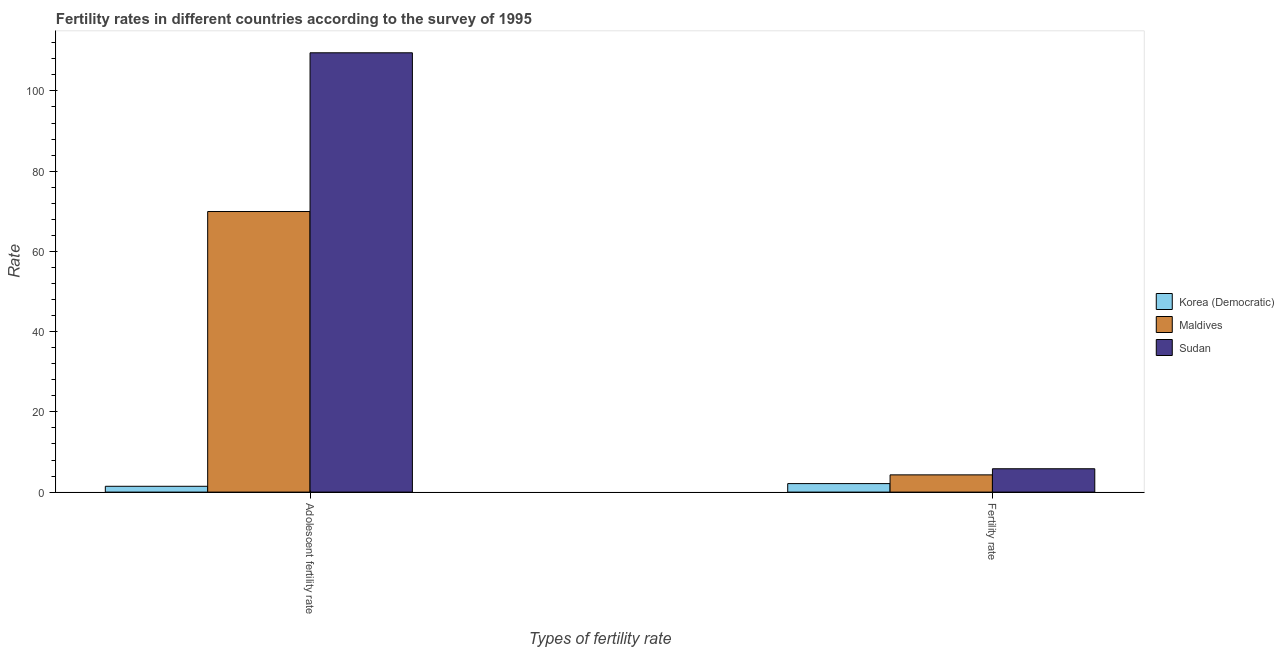Are the number of bars per tick equal to the number of legend labels?
Keep it short and to the point. Yes. Are the number of bars on each tick of the X-axis equal?
Your answer should be compact. Yes. How many bars are there on the 1st tick from the right?
Your response must be concise. 3. What is the label of the 1st group of bars from the left?
Keep it short and to the point. Adolescent fertility rate. What is the fertility rate in Korea (Democratic)?
Provide a short and direct response. 2.12. Across all countries, what is the maximum adolescent fertility rate?
Give a very brief answer. 109.5. Across all countries, what is the minimum fertility rate?
Your answer should be compact. 2.12. In which country was the adolescent fertility rate maximum?
Give a very brief answer. Sudan. In which country was the fertility rate minimum?
Your response must be concise. Korea (Democratic). What is the total adolescent fertility rate in the graph?
Provide a short and direct response. 180.89. What is the difference between the adolescent fertility rate in Sudan and that in Maldives?
Give a very brief answer. 39.56. What is the difference between the adolescent fertility rate in Maldives and the fertility rate in Korea (Democratic)?
Your answer should be compact. 67.82. What is the average adolescent fertility rate per country?
Make the answer very short. 60.3. What is the difference between the adolescent fertility rate and fertility rate in Maldives?
Provide a short and direct response. 65.64. In how many countries, is the fertility rate greater than 96 ?
Offer a terse response. 0. What is the ratio of the adolescent fertility rate in Sudan to that in Maldives?
Ensure brevity in your answer.  1.57. Is the adolescent fertility rate in Maldives less than that in Korea (Democratic)?
Provide a short and direct response. No. In how many countries, is the adolescent fertility rate greater than the average adolescent fertility rate taken over all countries?
Keep it short and to the point. 2. What does the 2nd bar from the left in Adolescent fertility rate represents?
Keep it short and to the point. Maldives. What does the 1st bar from the right in Adolescent fertility rate represents?
Offer a very short reply. Sudan. How many countries are there in the graph?
Your answer should be very brief. 3. Does the graph contain any zero values?
Provide a succinct answer. No. Where does the legend appear in the graph?
Your response must be concise. Center right. How many legend labels are there?
Offer a terse response. 3. What is the title of the graph?
Your answer should be compact. Fertility rates in different countries according to the survey of 1995. What is the label or title of the X-axis?
Your response must be concise. Types of fertility rate. What is the label or title of the Y-axis?
Your response must be concise. Rate. What is the Rate in Korea (Democratic) in Adolescent fertility rate?
Provide a succinct answer. 1.45. What is the Rate of Maldives in Adolescent fertility rate?
Your answer should be compact. 69.94. What is the Rate of Sudan in Adolescent fertility rate?
Make the answer very short. 109.5. What is the Rate in Korea (Democratic) in Fertility rate?
Provide a succinct answer. 2.12. What is the Rate of Maldives in Fertility rate?
Keep it short and to the point. 4.3. What is the Rate of Sudan in Fertility rate?
Keep it short and to the point. 5.82. Across all Types of fertility rate, what is the maximum Rate of Korea (Democratic)?
Your response must be concise. 2.12. Across all Types of fertility rate, what is the maximum Rate of Maldives?
Ensure brevity in your answer.  69.94. Across all Types of fertility rate, what is the maximum Rate in Sudan?
Your answer should be very brief. 109.5. Across all Types of fertility rate, what is the minimum Rate of Korea (Democratic)?
Offer a terse response. 1.45. Across all Types of fertility rate, what is the minimum Rate in Maldives?
Provide a succinct answer. 4.3. Across all Types of fertility rate, what is the minimum Rate of Sudan?
Your answer should be very brief. 5.82. What is the total Rate of Korea (Democratic) in the graph?
Your response must be concise. 3.57. What is the total Rate in Maldives in the graph?
Your answer should be very brief. 74.24. What is the total Rate in Sudan in the graph?
Your response must be concise. 115.32. What is the difference between the Rate in Korea (Democratic) in Adolescent fertility rate and that in Fertility rate?
Provide a succinct answer. -0.67. What is the difference between the Rate in Maldives in Adolescent fertility rate and that in Fertility rate?
Give a very brief answer. 65.64. What is the difference between the Rate of Sudan in Adolescent fertility rate and that in Fertility rate?
Your answer should be compact. 103.68. What is the difference between the Rate in Korea (Democratic) in Adolescent fertility rate and the Rate in Maldives in Fertility rate?
Give a very brief answer. -2.85. What is the difference between the Rate of Korea (Democratic) in Adolescent fertility rate and the Rate of Sudan in Fertility rate?
Make the answer very short. -4.37. What is the difference between the Rate in Maldives in Adolescent fertility rate and the Rate in Sudan in Fertility rate?
Ensure brevity in your answer.  64.12. What is the average Rate of Korea (Democratic) per Types of fertility rate?
Give a very brief answer. 1.79. What is the average Rate of Maldives per Types of fertility rate?
Give a very brief answer. 37.12. What is the average Rate in Sudan per Types of fertility rate?
Your answer should be compact. 57.66. What is the difference between the Rate in Korea (Democratic) and Rate in Maldives in Adolescent fertility rate?
Make the answer very short. -68.49. What is the difference between the Rate of Korea (Democratic) and Rate of Sudan in Adolescent fertility rate?
Keep it short and to the point. -108.05. What is the difference between the Rate in Maldives and Rate in Sudan in Adolescent fertility rate?
Your answer should be compact. -39.56. What is the difference between the Rate of Korea (Democratic) and Rate of Maldives in Fertility rate?
Your response must be concise. -2.18. What is the difference between the Rate in Maldives and Rate in Sudan in Fertility rate?
Ensure brevity in your answer.  -1.52. What is the ratio of the Rate in Korea (Democratic) in Adolescent fertility rate to that in Fertility rate?
Offer a terse response. 0.68. What is the ratio of the Rate of Maldives in Adolescent fertility rate to that in Fertility rate?
Your response must be concise. 16.27. What is the ratio of the Rate of Sudan in Adolescent fertility rate to that in Fertility rate?
Your response must be concise. 18.81. What is the difference between the highest and the second highest Rate of Korea (Democratic)?
Provide a short and direct response. 0.67. What is the difference between the highest and the second highest Rate in Maldives?
Your answer should be compact. 65.64. What is the difference between the highest and the second highest Rate of Sudan?
Your answer should be very brief. 103.68. What is the difference between the highest and the lowest Rate of Korea (Democratic)?
Provide a succinct answer. 0.67. What is the difference between the highest and the lowest Rate of Maldives?
Provide a short and direct response. 65.64. What is the difference between the highest and the lowest Rate of Sudan?
Provide a short and direct response. 103.68. 